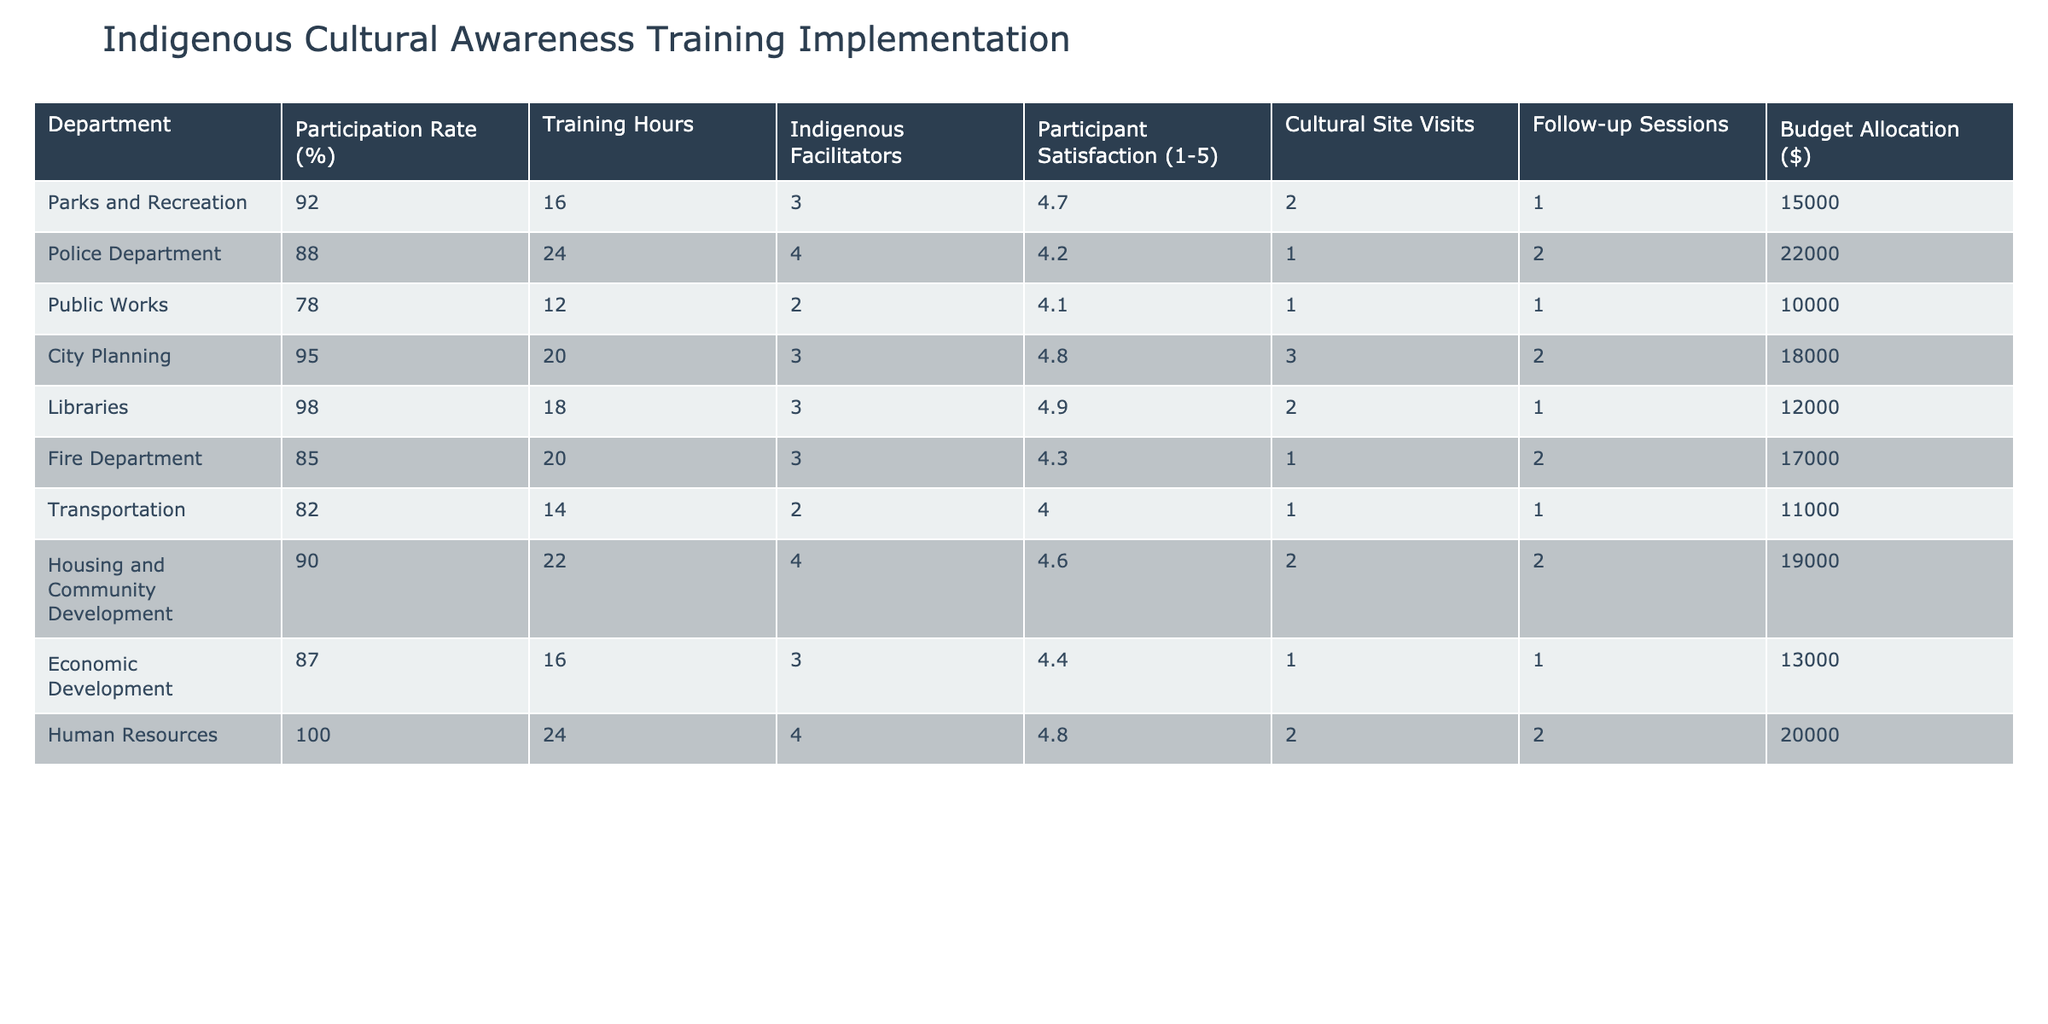What is the participation rate of the Human Resources department? The participation rate for Human Resources is listed in the table under the "Participation Rate (%)" column. Looking at that row, it shows 100%.
Answer: 100% Which department had the highest participant satisfaction rating? To find the highest satisfaction rating, we look at the "Participant Satisfaction (1-5)" column and identify the maximum value. The highest rating is 4.9 from the Libraries department.
Answer: Libraries How many training hours did the Police Department conduct? The training hours for the Police Department can be found directly in the "Training Hours" column under the row for the Police Department. It shows 24 hours.
Answer: 24 What is the average budget allocation for departments that conducted follow-up sessions? First, we identify the departments with follow-up sessions, which are the Police Department, Fire Department, Housing and Community Development, and Human Resources. Next, we sum their budget allocations: 22000 + 17000 + 19000 + 20000 = 78000. Finally, we divide by the number of departments (4) to find the average: 78000 / 4 = 19500.
Answer: 19500 Is it true that the Parks and Recreation department had more cultural site visits than the Transportation department? Comparing the "Cultural Site Visits" values, Parks and Recreation has 2 visits listed, while Transportation has only 1. Therefore, the statement is true.
Answer: Yes What is the difference in training hours between the City Planning and Public Works departments? The training hours for City Planning is 20 hours and for Public Works is 12 hours. To find the difference, we subtract 12 from 20, resulting in 8 hours.
Answer: 8 How many departments had a participation rate below 90%? We review the "Participation Rate (%)" column and note the departments with rates below 90%. Public Works (78%), Transportation (82%), and Economic Development (87%) fall into this category, totaling 3 departments.
Answer: 3 Did any department have a participation rate above 95% while also utilizing indigenous facilitators? The City Planning (95%) and Libraries (98%) departments both have participation rates above 95%. Both also used indigenous facilitators (3 for City Planning and 3 for Libraries), making the statement true.
Answer: Yes What is the median participant satisfaction rating for all departments? To find the median, we list the satisfaction ratings: 4.7, 4.2, 4.1, 4.8, 4.9, 4.3, 4.0, 4.6, 4.4, 4.8. Once sorted, we have: 4.0, 4.1, 4.2, 4.3, 4.4, 4.6, 4.7, 4.8, 4.8, 4.9. The median of the 10 values is the average of the 5th and 6th values, which is (4.4 + 4.6) / 2 = 4.5.
Answer: 4.5 